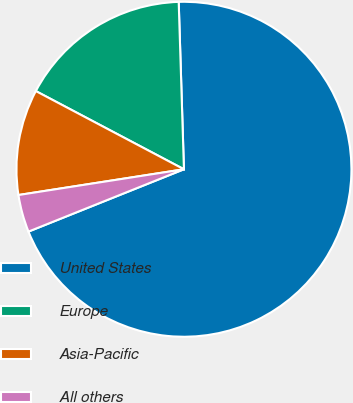Convert chart to OTSL. <chart><loc_0><loc_0><loc_500><loc_500><pie_chart><fcel>United States<fcel>Europe<fcel>Asia-Pacific<fcel>All others<nl><fcel>69.43%<fcel>16.77%<fcel>10.19%<fcel>3.61%<nl></chart> 